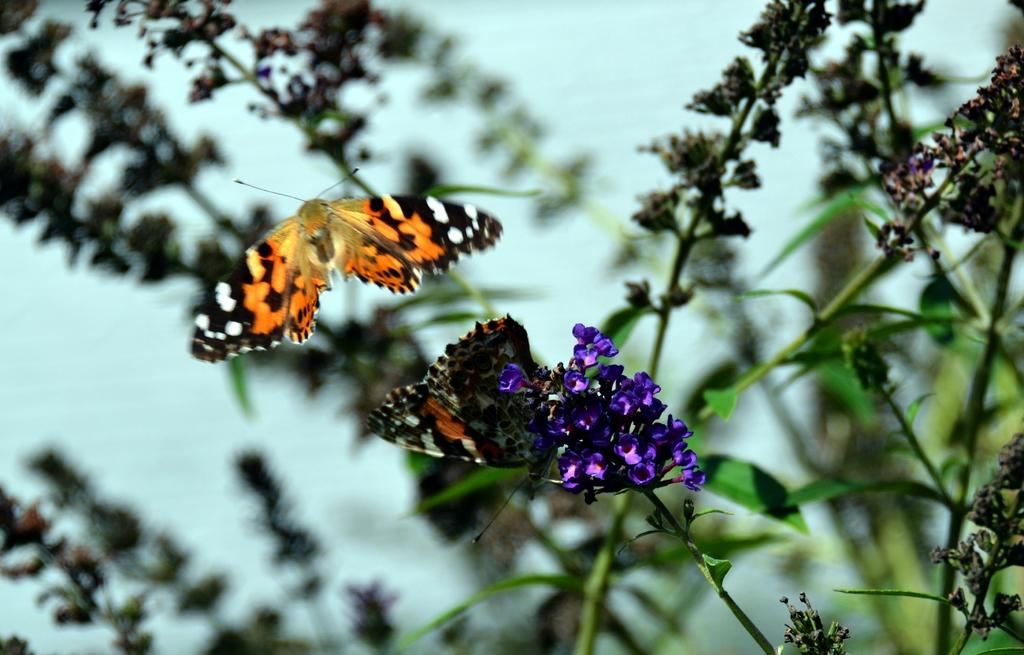What is present in the image? There is a plant in the image. What can be seen on the plant? There are butterflies and flowers on the plant. What else is part of the plant's structure? There are leaves on the plant. What type of tent can be seen in the image? There is no tent present in the image. What kind of laborer is working on the plant in the image? There is no laborer present in the image; it is a plant with butterflies and flowers. 